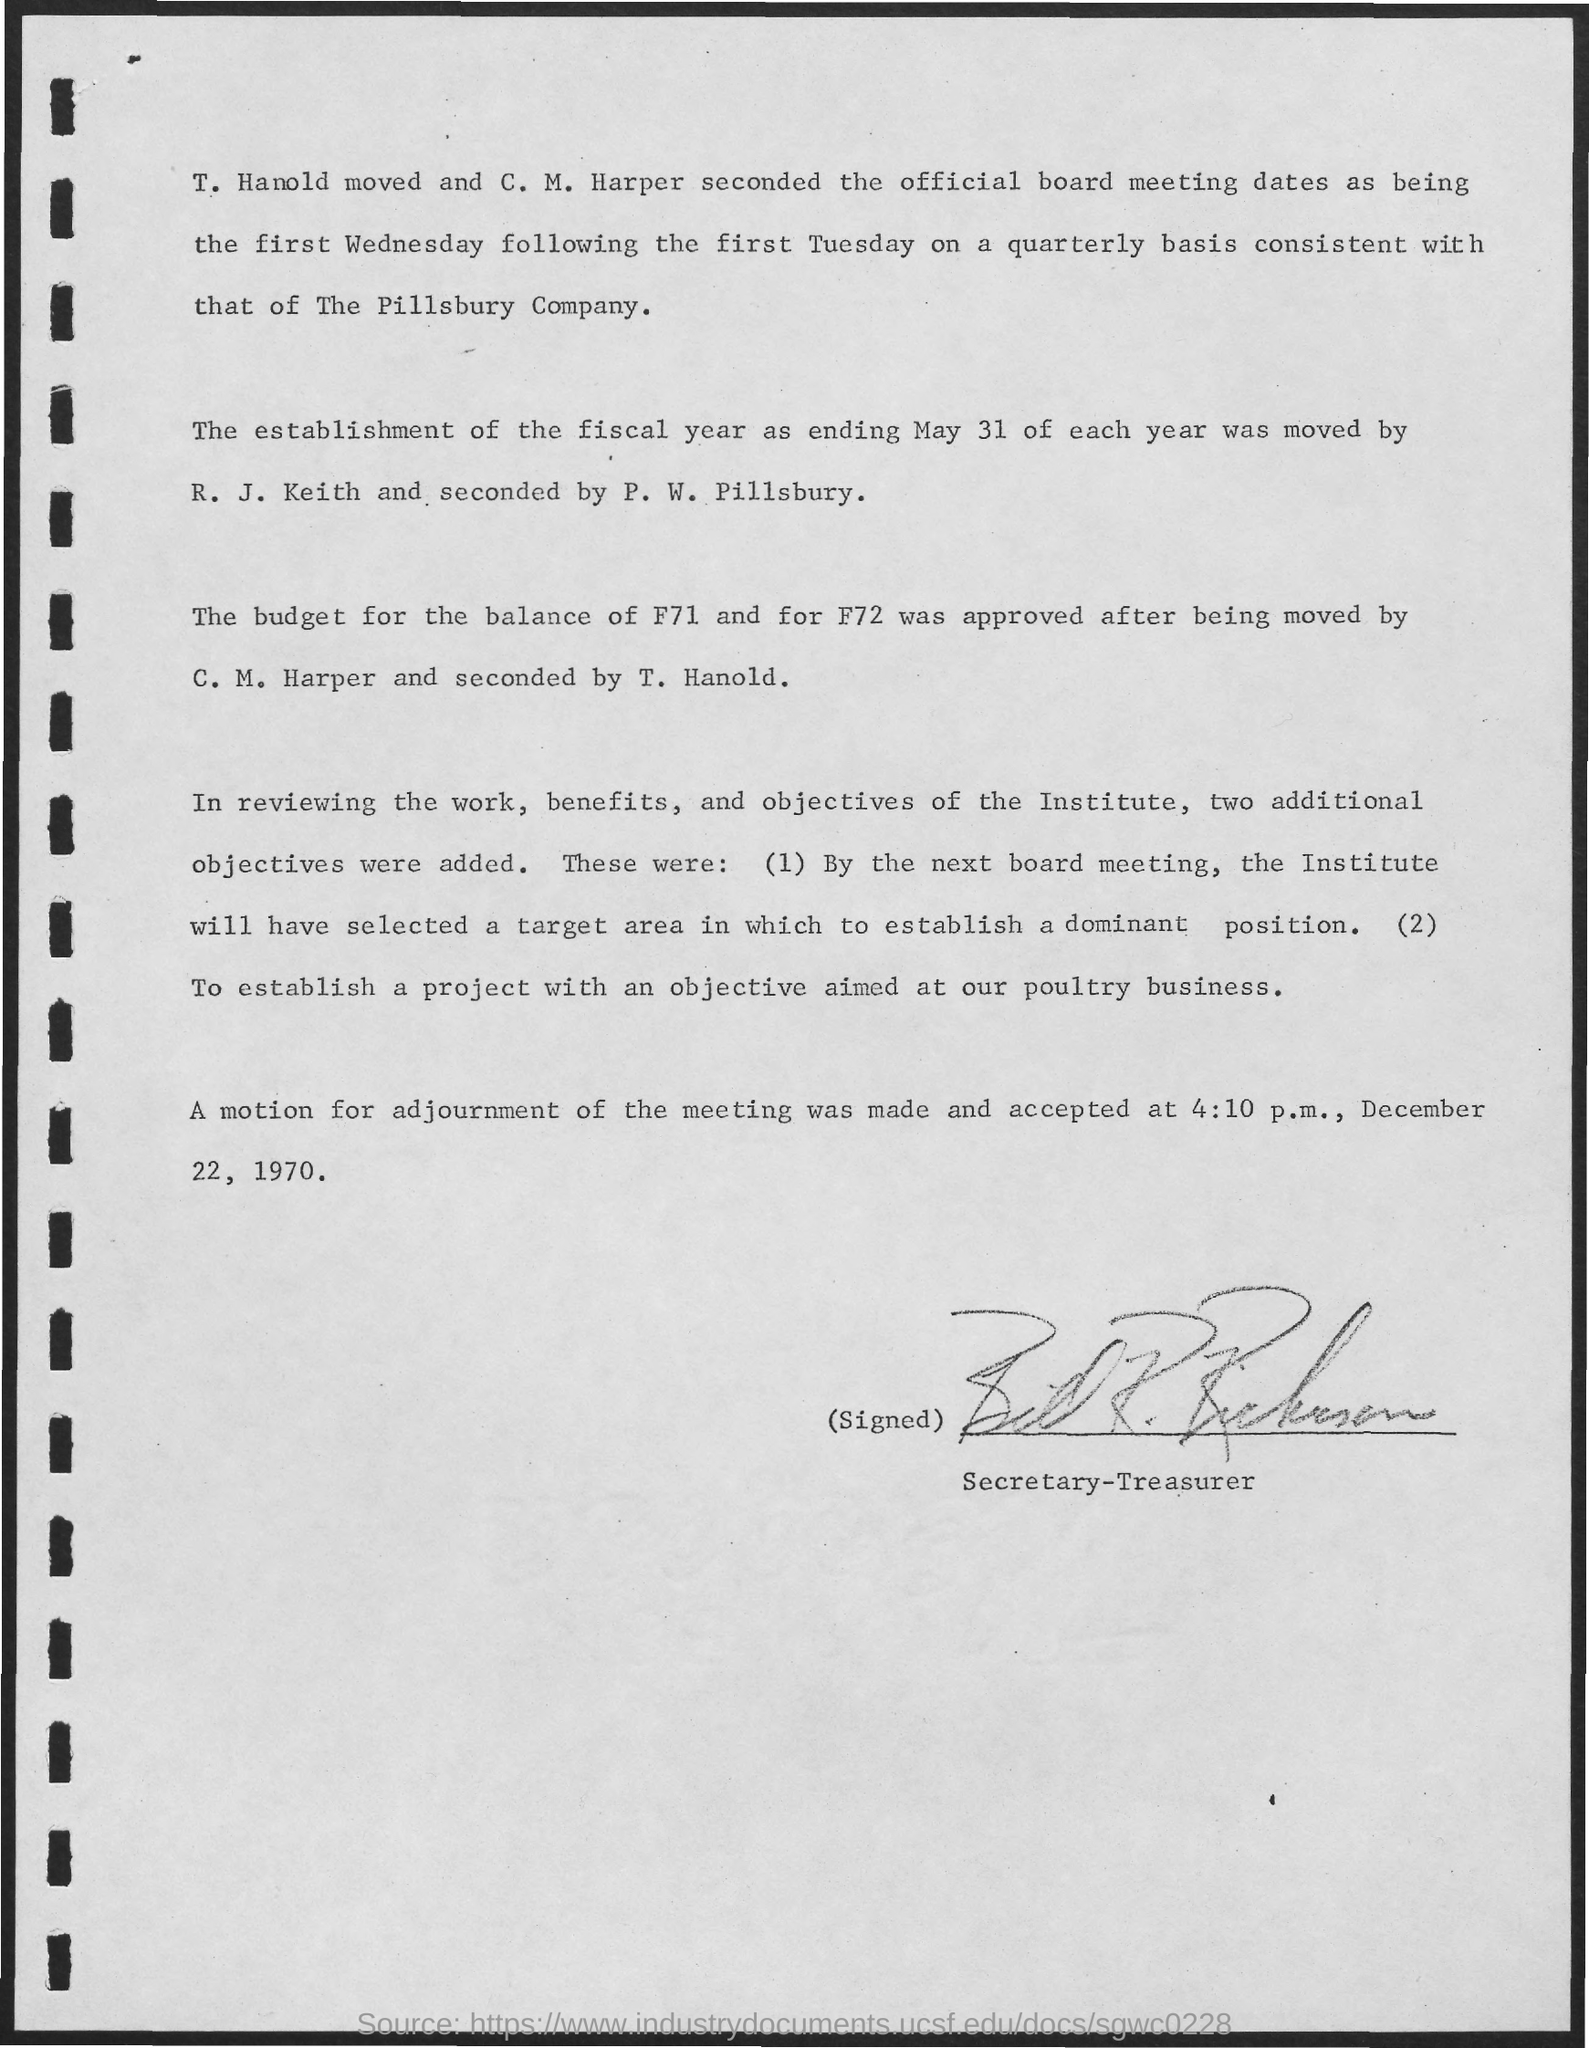List a handful of essential elements in this visual. The date mentioned at the bottom of the document is December 22, 1970. The time mentioned in the document is 4:10 p.m. 